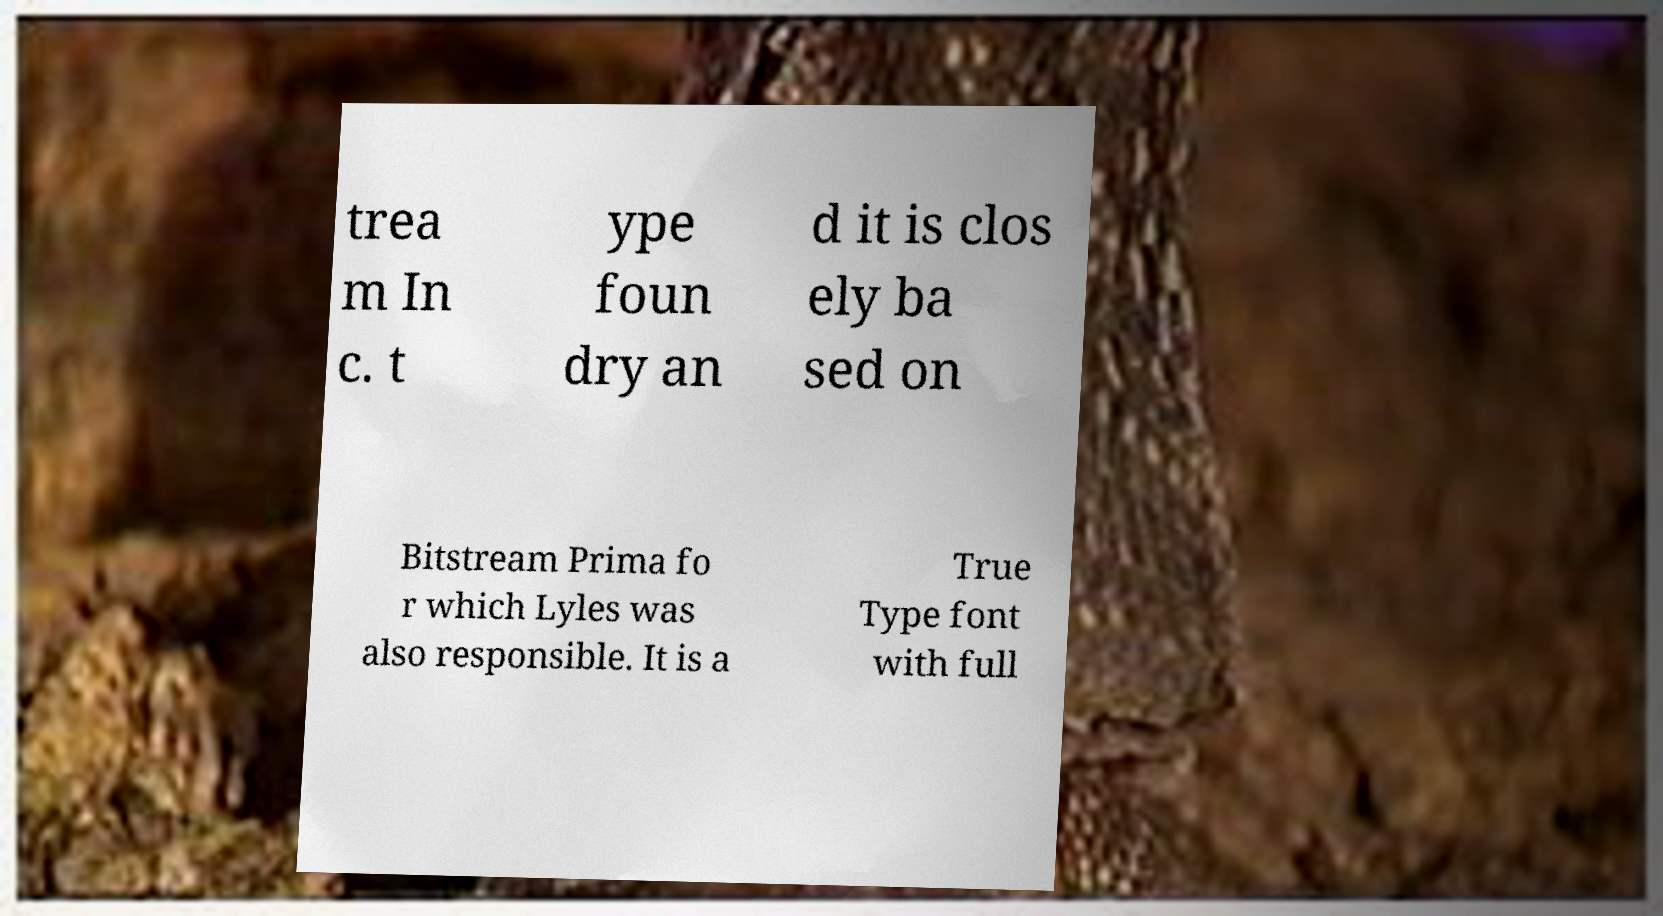Can you read and provide the text displayed in the image?This photo seems to have some interesting text. Can you extract and type it out for me? trea m In c. t ype foun dry an d it is clos ely ba sed on Bitstream Prima fo r which Lyles was also responsible. It is a True Type font with full 